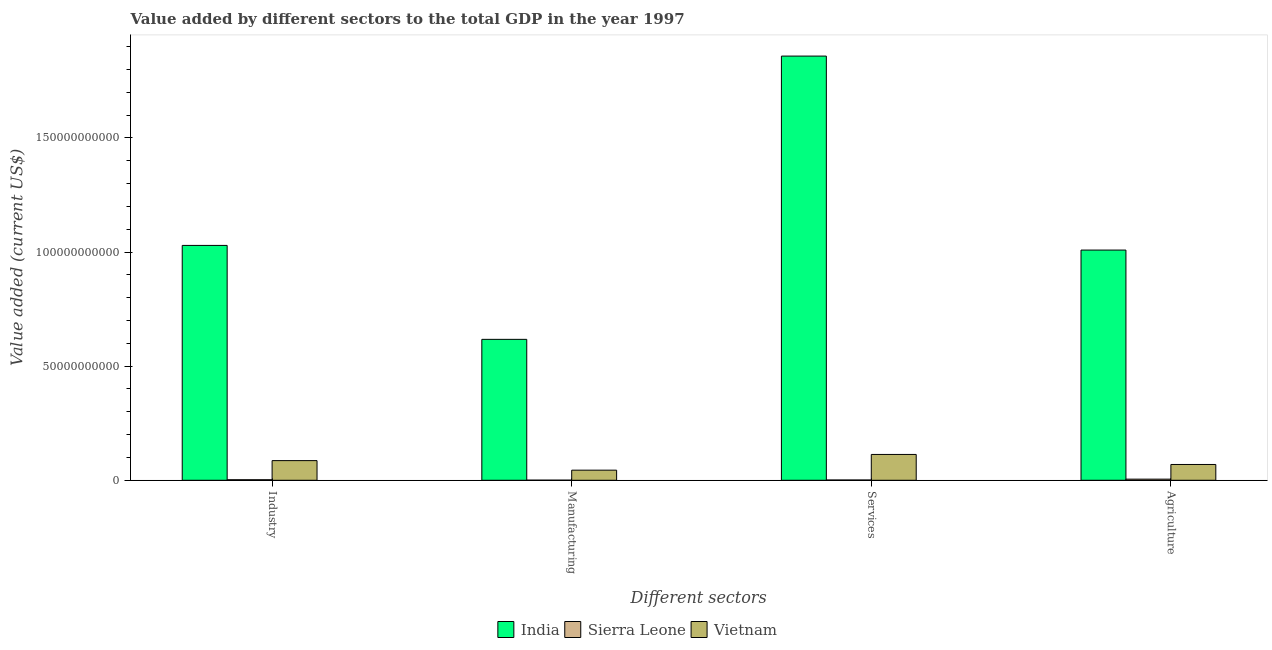Are the number of bars per tick equal to the number of legend labels?
Provide a short and direct response. Yes. Are the number of bars on each tick of the X-axis equal?
Give a very brief answer. Yes. How many bars are there on the 3rd tick from the left?
Give a very brief answer. 3. How many bars are there on the 2nd tick from the right?
Offer a very short reply. 3. What is the label of the 4th group of bars from the left?
Offer a very short reply. Agriculture. What is the value added by services sector in Vietnam?
Offer a terse response. 1.13e+1. Across all countries, what is the maximum value added by agricultural sector?
Give a very brief answer. 1.01e+11. Across all countries, what is the minimum value added by services sector?
Ensure brevity in your answer.  1.14e+08. In which country was the value added by agricultural sector maximum?
Your answer should be very brief. India. In which country was the value added by agricultural sector minimum?
Your answer should be very brief. Sierra Leone. What is the total value added by industrial sector in the graph?
Provide a succinct answer. 1.12e+11. What is the difference between the value added by industrial sector in Sierra Leone and that in Vietnam?
Provide a short and direct response. -8.38e+09. What is the difference between the value added by manufacturing sector in Vietnam and the value added by services sector in India?
Keep it short and to the point. -1.81e+11. What is the average value added by services sector per country?
Provide a short and direct response. 6.58e+1. What is the difference between the value added by services sector and value added by agricultural sector in India?
Offer a very short reply. 8.50e+1. In how many countries, is the value added by industrial sector greater than 30000000000 US$?
Provide a short and direct response. 1. What is the ratio of the value added by manufacturing sector in Sierra Leone to that in Vietnam?
Ensure brevity in your answer.  0.01. Is the difference between the value added by agricultural sector in Sierra Leone and India greater than the difference between the value added by services sector in Sierra Leone and India?
Give a very brief answer. Yes. What is the difference between the highest and the second highest value added by services sector?
Provide a short and direct response. 1.75e+11. What is the difference between the highest and the lowest value added by manufacturing sector?
Offer a terse response. 6.17e+1. In how many countries, is the value added by services sector greater than the average value added by services sector taken over all countries?
Provide a short and direct response. 1. Is it the case that in every country, the sum of the value added by manufacturing sector and value added by industrial sector is greater than the sum of value added by services sector and value added by agricultural sector?
Make the answer very short. No. What does the 2nd bar from the left in Manufacturing represents?
Give a very brief answer. Sierra Leone. What does the 3rd bar from the right in Industry represents?
Provide a succinct answer. India. Is it the case that in every country, the sum of the value added by industrial sector and value added by manufacturing sector is greater than the value added by services sector?
Ensure brevity in your answer.  No. How many countries are there in the graph?
Your answer should be compact. 3. Are the values on the major ticks of Y-axis written in scientific E-notation?
Ensure brevity in your answer.  No. Does the graph contain any zero values?
Make the answer very short. No. Where does the legend appear in the graph?
Offer a very short reply. Bottom center. How are the legend labels stacked?
Offer a very short reply. Horizontal. What is the title of the graph?
Offer a very short reply. Value added by different sectors to the total GDP in the year 1997. What is the label or title of the X-axis?
Your answer should be compact. Different sectors. What is the label or title of the Y-axis?
Offer a very short reply. Value added (current US$). What is the Value added (current US$) in India in Industry?
Make the answer very short. 1.03e+11. What is the Value added (current US$) in Sierra Leone in Industry?
Your answer should be very brief. 2.30e+08. What is the Value added (current US$) of Vietnam in Industry?
Provide a succinct answer. 8.61e+09. What is the Value added (current US$) of India in Manufacturing?
Keep it short and to the point. 6.17e+1. What is the Value added (current US$) in Sierra Leone in Manufacturing?
Provide a short and direct response. 4.07e+07. What is the Value added (current US$) in Vietnam in Manufacturing?
Keep it short and to the point. 4.43e+09. What is the Value added (current US$) of India in Services?
Provide a succinct answer. 1.86e+11. What is the Value added (current US$) in Sierra Leone in Services?
Ensure brevity in your answer.  1.14e+08. What is the Value added (current US$) of Vietnam in Services?
Your answer should be very brief. 1.13e+1. What is the Value added (current US$) of India in Agriculture?
Give a very brief answer. 1.01e+11. What is the Value added (current US$) of Sierra Leone in Agriculture?
Offer a terse response. 4.88e+08. What is the Value added (current US$) of Vietnam in Agriculture?
Provide a succinct answer. 6.92e+09. Across all Different sectors, what is the maximum Value added (current US$) of India?
Offer a very short reply. 1.86e+11. Across all Different sectors, what is the maximum Value added (current US$) of Sierra Leone?
Give a very brief answer. 4.88e+08. Across all Different sectors, what is the maximum Value added (current US$) of Vietnam?
Your response must be concise. 1.13e+1. Across all Different sectors, what is the minimum Value added (current US$) of India?
Your answer should be compact. 6.17e+1. Across all Different sectors, what is the minimum Value added (current US$) of Sierra Leone?
Offer a terse response. 4.07e+07. Across all Different sectors, what is the minimum Value added (current US$) in Vietnam?
Provide a succinct answer. 4.43e+09. What is the total Value added (current US$) of India in the graph?
Offer a terse response. 4.51e+11. What is the total Value added (current US$) of Sierra Leone in the graph?
Provide a succinct answer. 8.73e+08. What is the total Value added (current US$) in Vietnam in the graph?
Offer a terse response. 3.13e+1. What is the difference between the Value added (current US$) of India in Industry and that in Manufacturing?
Keep it short and to the point. 4.12e+1. What is the difference between the Value added (current US$) in Sierra Leone in Industry and that in Manufacturing?
Offer a terse response. 1.90e+08. What is the difference between the Value added (current US$) of Vietnam in Industry and that in Manufacturing?
Provide a succinct answer. 4.18e+09. What is the difference between the Value added (current US$) of India in Industry and that in Services?
Your answer should be very brief. -8.30e+1. What is the difference between the Value added (current US$) of Sierra Leone in Industry and that in Services?
Provide a succinct answer. 1.17e+08. What is the difference between the Value added (current US$) of Vietnam in Industry and that in Services?
Keep it short and to the point. -2.71e+09. What is the difference between the Value added (current US$) in India in Industry and that in Agriculture?
Your answer should be compact. 2.04e+09. What is the difference between the Value added (current US$) of Sierra Leone in Industry and that in Agriculture?
Give a very brief answer. -2.58e+08. What is the difference between the Value added (current US$) of Vietnam in Industry and that in Agriculture?
Provide a short and direct response. 1.69e+09. What is the difference between the Value added (current US$) of India in Manufacturing and that in Services?
Your response must be concise. -1.24e+11. What is the difference between the Value added (current US$) in Sierra Leone in Manufacturing and that in Services?
Keep it short and to the point. -7.30e+07. What is the difference between the Value added (current US$) in Vietnam in Manufacturing and that in Services?
Provide a short and direct response. -6.89e+09. What is the difference between the Value added (current US$) of India in Manufacturing and that in Agriculture?
Your response must be concise. -3.91e+1. What is the difference between the Value added (current US$) in Sierra Leone in Manufacturing and that in Agriculture?
Your response must be concise. -4.47e+08. What is the difference between the Value added (current US$) in Vietnam in Manufacturing and that in Agriculture?
Ensure brevity in your answer.  -2.49e+09. What is the difference between the Value added (current US$) in India in Services and that in Agriculture?
Keep it short and to the point. 8.50e+1. What is the difference between the Value added (current US$) in Sierra Leone in Services and that in Agriculture?
Ensure brevity in your answer.  -3.74e+08. What is the difference between the Value added (current US$) of Vietnam in Services and that in Agriculture?
Offer a terse response. 4.40e+09. What is the difference between the Value added (current US$) of India in Industry and the Value added (current US$) of Sierra Leone in Manufacturing?
Offer a terse response. 1.03e+11. What is the difference between the Value added (current US$) in India in Industry and the Value added (current US$) in Vietnam in Manufacturing?
Give a very brief answer. 9.85e+1. What is the difference between the Value added (current US$) in Sierra Leone in Industry and the Value added (current US$) in Vietnam in Manufacturing?
Your answer should be compact. -4.19e+09. What is the difference between the Value added (current US$) of India in Industry and the Value added (current US$) of Sierra Leone in Services?
Give a very brief answer. 1.03e+11. What is the difference between the Value added (current US$) in India in Industry and the Value added (current US$) in Vietnam in Services?
Ensure brevity in your answer.  9.16e+1. What is the difference between the Value added (current US$) of Sierra Leone in Industry and the Value added (current US$) of Vietnam in Services?
Offer a very short reply. -1.11e+1. What is the difference between the Value added (current US$) of India in Industry and the Value added (current US$) of Sierra Leone in Agriculture?
Make the answer very short. 1.02e+11. What is the difference between the Value added (current US$) of India in Industry and the Value added (current US$) of Vietnam in Agriculture?
Your response must be concise. 9.60e+1. What is the difference between the Value added (current US$) of Sierra Leone in Industry and the Value added (current US$) of Vietnam in Agriculture?
Your answer should be very brief. -6.69e+09. What is the difference between the Value added (current US$) of India in Manufacturing and the Value added (current US$) of Sierra Leone in Services?
Your answer should be compact. 6.16e+1. What is the difference between the Value added (current US$) in India in Manufacturing and the Value added (current US$) in Vietnam in Services?
Provide a succinct answer. 5.04e+1. What is the difference between the Value added (current US$) of Sierra Leone in Manufacturing and the Value added (current US$) of Vietnam in Services?
Keep it short and to the point. -1.13e+1. What is the difference between the Value added (current US$) in India in Manufacturing and the Value added (current US$) in Sierra Leone in Agriculture?
Provide a succinct answer. 6.12e+1. What is the difference between the Value added (current US$) of India in Manufacturing and the Value added (current US$) of Vietnam in Agriculture?
Give a very brief answer. 5.48e+1. What is the difference between the Value added (current US$) of Sierra Leone in Manufacturing and the Value added (current US$) of Vietnam in Agriculture?
Offer a very short reply. -6.88e+09. What is the difference between the Value added (current US$) of India in Services and the Value added (current US$) of Sierra Leone in Agriculture?
Ensure brevity in your answer.  1.85e+11. What is the difference between the Value added (current US$) in India in Services and the Value added (current US$) in Vietnam in Agriculture?
Keep it short and to the point. 1.79e+11. What is the difference between the Value added (current US$) in Sierra Leone in Services and the Value added (current US$) in Vietnam in Agriculture?
Your answer should be compact. -6.80e+09. What is the average Value added (current US$) in India per Different sectors?
Your response must be concise. 1.13e+11. What is the average Value added (current US$) in Sierra Leone per Different sectors?
Provide a succinct answer. 2.18e+08. What is the average Value added (current US$) of Vietnam per Different sectors?
Give a very brief answer. 7.82e+09. What is the difference between the Value added (current US$) of India and Value added (current US$) of Sierra Leone in Industry?
Provide a succinct answer. 1.03e+11. What is the difference between the Value added (current US$) in India and Value added (current US$) in Vietnam in Industry?
Your response must be concise. 9.43e+1. What is the difference between the Value added (current US$) of Sierra Leone and Value added (current US$) of Vietnam in Industry?
Offer a terse response. -8.38e+09. What is the difference between the Value added (current US$) of India and Value added (current US$) of Sierra Leone in Manufacturing?
Make the answer very short. 6.17e+1. What is the difference between the Value added (current US$) in India and Value added (current US$) in Vietnam in Manufacturing?
Give a very brief answer. 5.73e+1. What is the difference between the Value added (current US$) of Sierra Leone and Value added (current US$) of Vietnam in Manufacturing?
Offer a terse response. -4.38e+09. What is the difference between the Value added (current US$) of India and Value added (current US$) of Sierra Leone in Services?
Make the answer very short. 1.86e+11. What is the difference between the Value added (current US$) in India and Value added (current US$) in Vietnam in Services?
Give a very brief answer. 1.75e+11. What is the difference between the Value added (current US$) in Sierra Leone and Value added (current US$) in Vietnam in Services?
Give a very brief answer. -1.12e+1. What is the difference between the Value added (current US$) in India and Value added (current US$) in Sierra Leone in Agriculture?
Keep it short and to the point. 1.00e+11. What is the difference between the Value added (current US$) in India and Value added (current US$) in Vietnam in Agriculture?
Your response must be concise. 9.39e+1. What is the difference between the Value added (current US$) in Sierra Leone and Value added (current US$) in Vietnam in Agriculture?
Offer a very short reply. -6.43e+09. What is the ratio of the Value added (current US$) in India in Industry to that in Manufacturing?
Give a very brief answer. 1.67. What is the ratio of the Value added (current US$) of Sierra Leone in Industry to that in Manufacturing?
Ensure brevity in your answer.  5.66. What is the ratio of the Value added (current US$) of Vietnam in Industry to that in Manufacturing?
Provide a short and direct response. 1.95. What is the ratio of the Value added (current US$) in India in Industry to that in Services?
Your answer should be very brief. 0.55. What is the ratio of the Value added (current US$) in Sierra Leone in Industry to that in Services?
Your response must be concise. 2.03. What is the ratio of the Value added (current US$) in Vietnam in Industry to that in Services?
Your answer should be compact. 0.76. What is the ratio of the Value added (current US$) in India in Industry to that in Agriculture?
Your answer should be very brief. 1.02. What is the ratio of the Value added (current US$) of Sierra Leone in Industry to that in Agriculture?
Give a very brief answer. 0.47. What is the ratio of the Value added (current US$) of Vietnam in Industry to that in Agriculture?
Offer a very short reply. 1.24. What is the ratio of the Value added (current US$) in India in Manufacturing to that in Services?
Offer a terse response. 0.33. What is the ratio of the Value added (current US$) of Sierra Leone in Manufacturing to that in Services?
Provide a succinct answer. 0.36. What is the ratio of the Value added (current US$) of Vietnam in Manufacturing to that in Services?
Provide a succinct answer. 0.39. What is the ratio of the Value added (current US$) of India in Manufacturing to that in Agriculture?
Ensure brevity in your answer.  0.61. What is the ratio of the Value added (current US$) in Sierra Leone in Manufacturing to that in Agriculture?
Your answer should be very brief. 0.08. What is the ratio of the Value added (current US$) in Vietnam in Manufacturing to that in Agriculture?
Offer a terse response. 0.64. What is the ratio of the Value added (current US$) of India in Services to that in Agriculture?
Your response must be concise. 1.84. What is the ratio of the Value added (current US$) of Sierra Leone in Services to that in Agriculture?
Your answer should be compact. 0.23. What is the ratio of the Value added (current US$) in Vietnam in Services to that in Agriculture?
Your response must be concise. 1.64. What is the difference between the highest and the second highest Value added (current US$) of India?
Your answer should be compact. 8.30e+1. What is the difference between the highest and the second highest Value added (current US$) of Sierra Leone?
Offer a very short reply. 2.58e+08. What is the difference between the highest and the second highest Value added (current US$) in Vietnam?
Provide a succinct answer. 2.71e+09. What is the difference between the highest and the lowest Value added (current US$) in India?
Offer a terse response. 1.24e+11. What is the difference between the highest and the lowest Value added (current US$) in Sierra Leone?
Your response must be concise. 4.47e+08. What is the difference between the highest and the lowest Value added (current US$) of Vietnam?
Provide a short and direct response. 6.89e+09. 